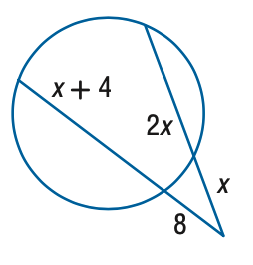Question: Find the variable of x to the nearest tenth.
Choices:
A. 6.1
B. 6.6
C. 7.1
D. 7.6
Answer with the letter. Answer: C 